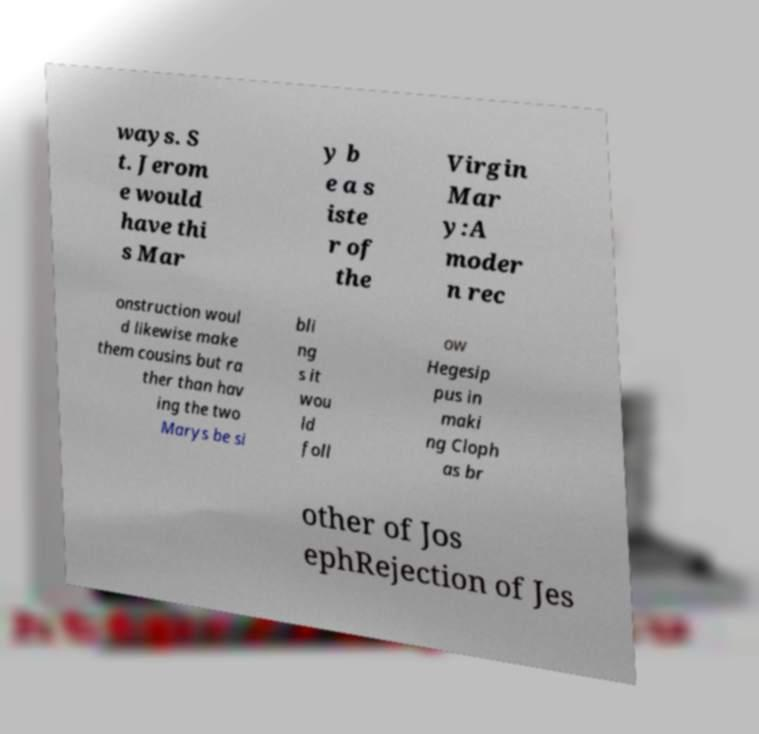For documentation purposes, I need the text within this image transcribed. Could you provide that? ways. S t. Jerom e would have thi s Mar y b e a s iste r of the Virgin Mar y:A moder n rec onstruction woul d likewise make them cousins but ra ther than hav ing the two Marys be si bli ng s it wou ld foll ow Hegesip pus in maki ng Cloph as br other of Jos ephRejection of Jes 